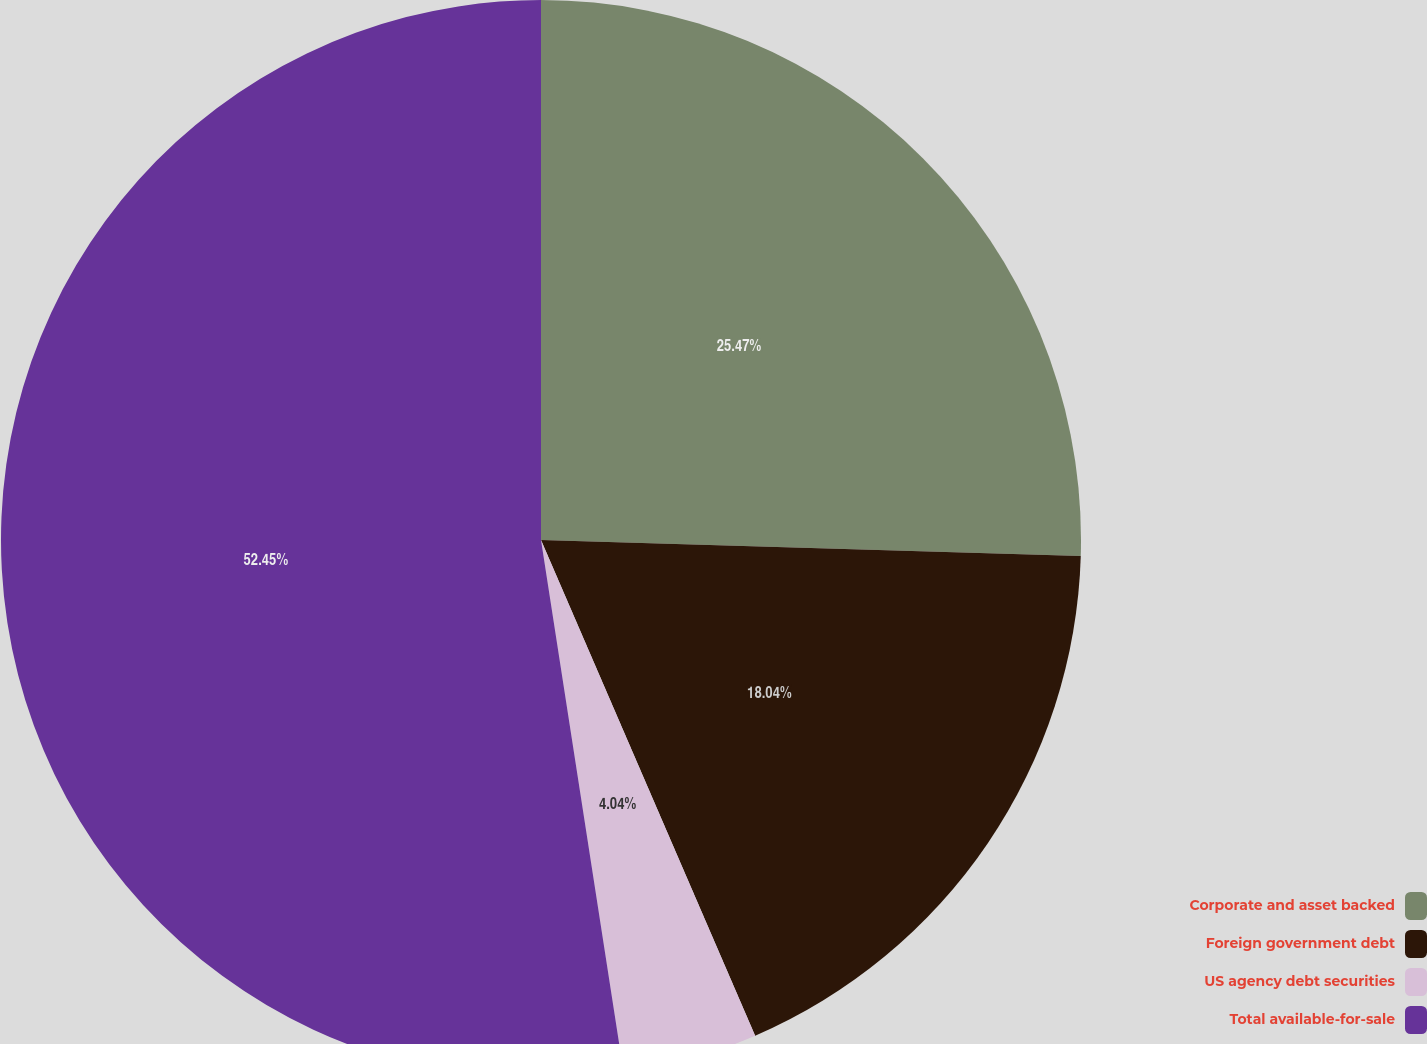<chart> <loc_0><loc_0><loc_500><loc_500><pie_chart><fcel>Corporate and asset backed<fcel>Foreign government debt<fcel>US agency debt securities<fcel>Total available-for-sale<nl><fcel>25.47%<fcel>18.04%<fcel>4.04%<fcel>52.45%<nl></chart> 